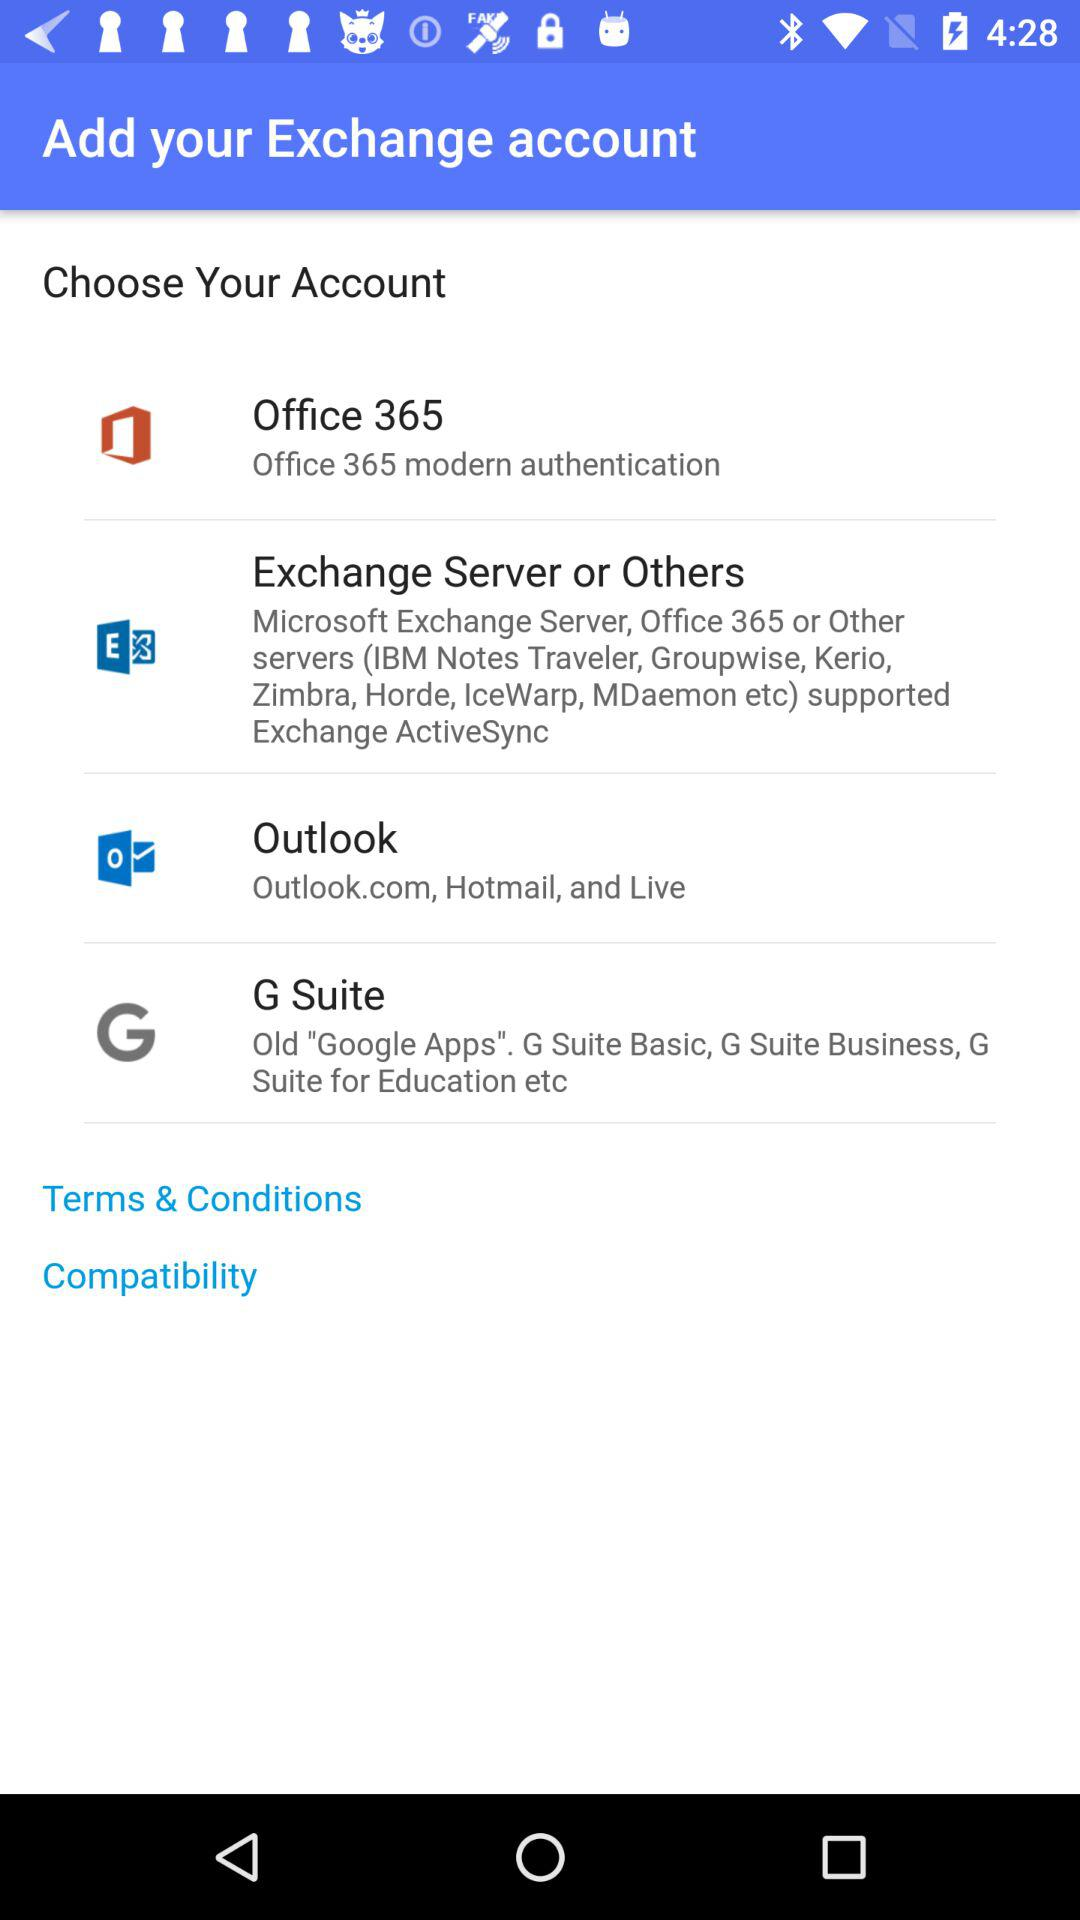What are the different options for exchange accounts? The different options for exchange accounts are "Office 365", "Exchange Server or Others", "Outlook" and "G Suite". 